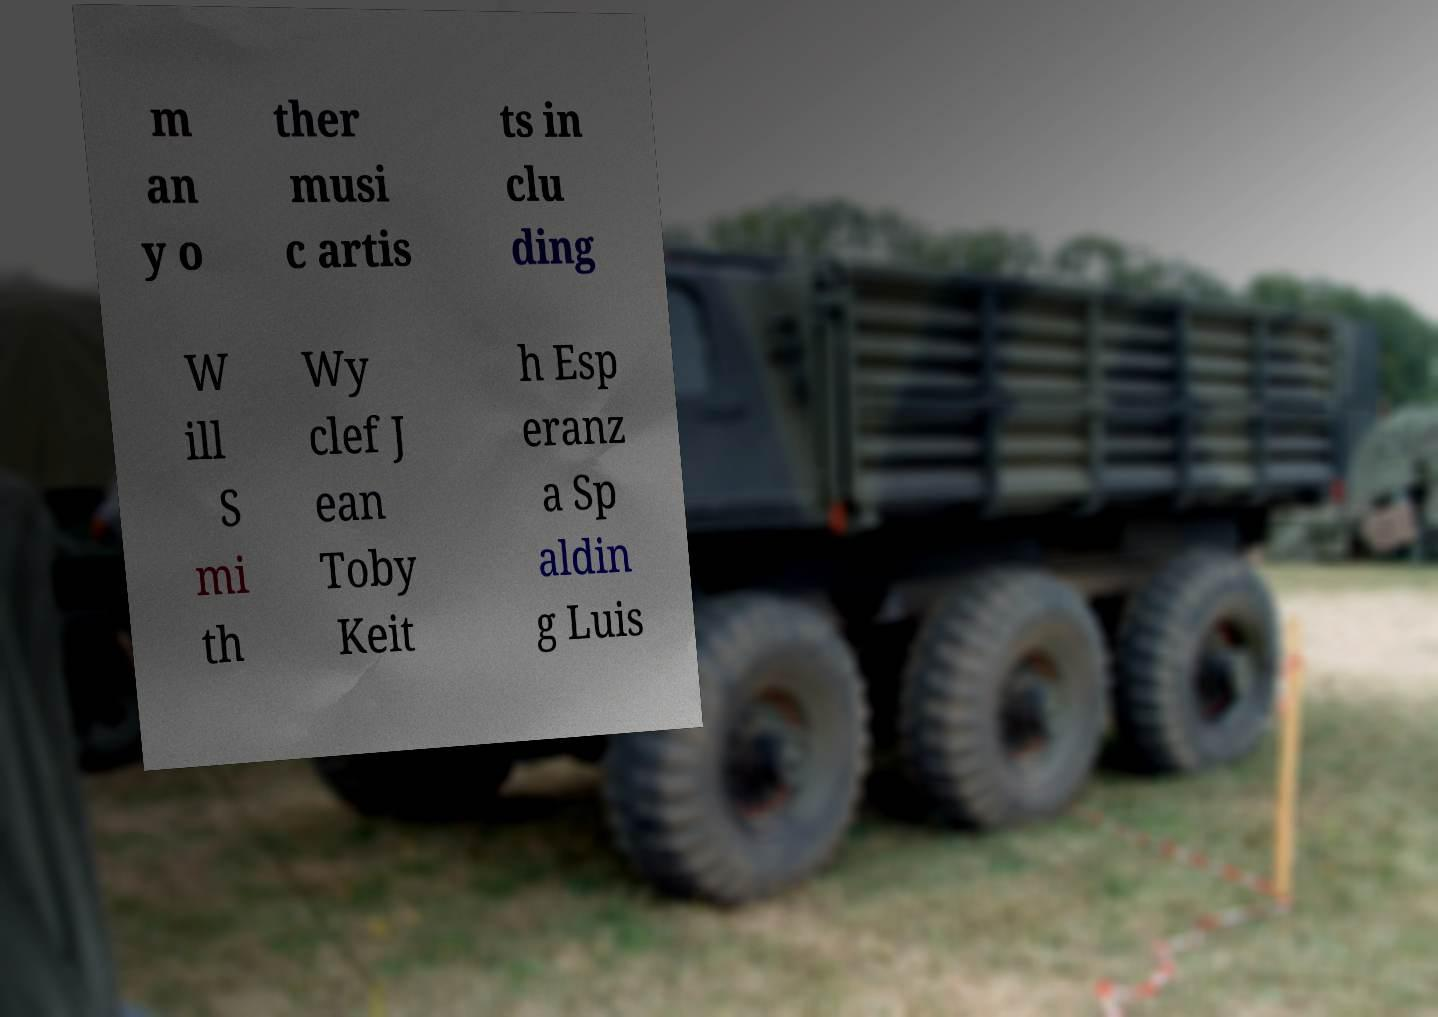Could you extract and type out the text from this image? m an y o ther musi c artis ts in clu ding W ill S mi th Wy clef J ean Toby Keit h Esp eranz a Sp aldin g Luis 